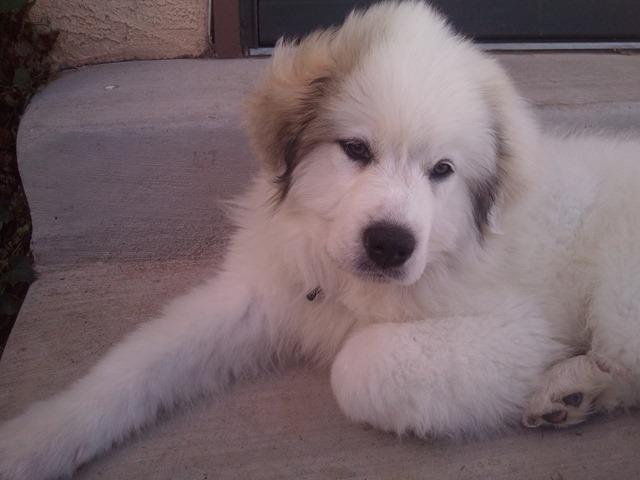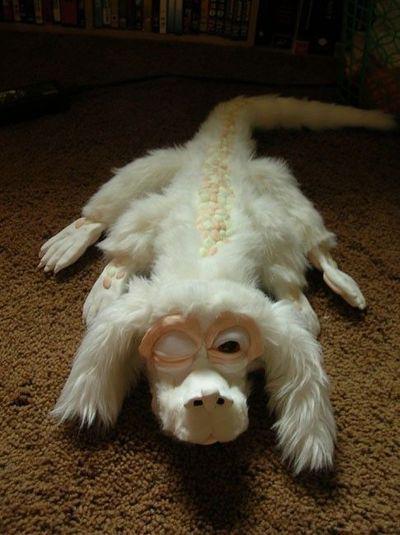The first image is the image on the left, the second image is the image on the right. Assess this claim about the two images: "At least one image has dogs sitting on grass.". Correct or not? Answer yes or no. No. 